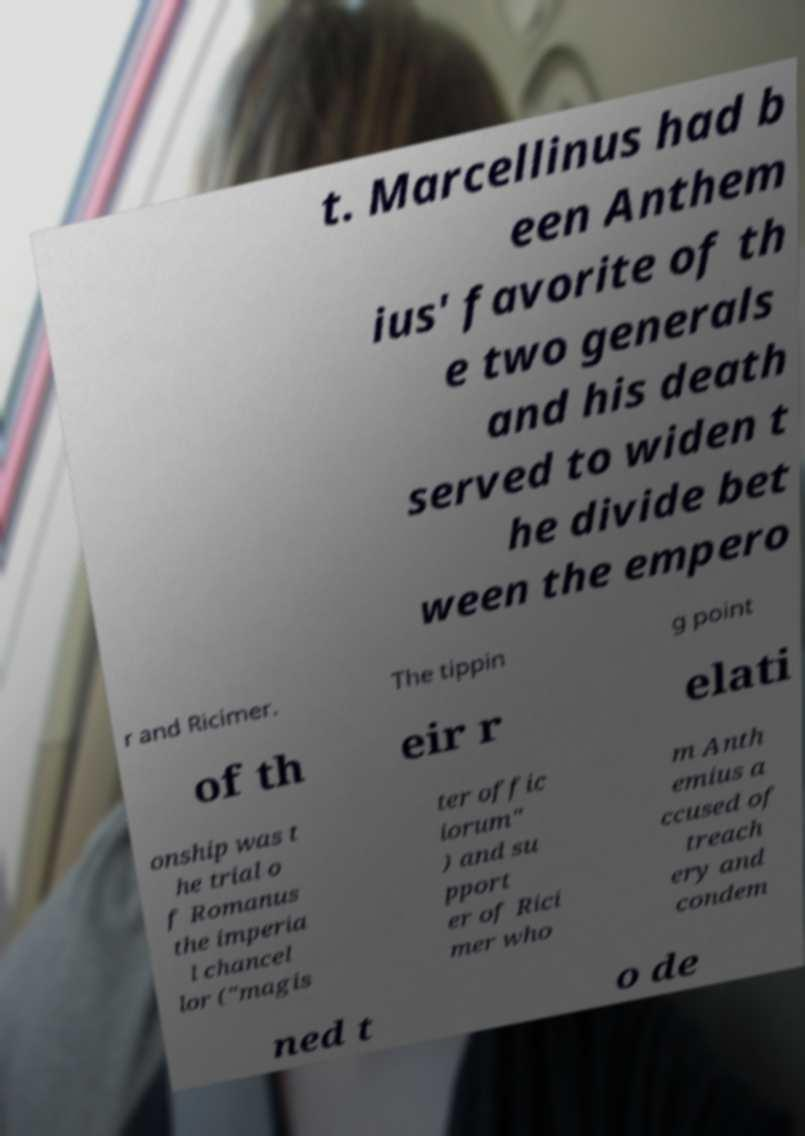I need the written content from this picture converted into text. Can you do that? t. Marcellinus had b een Anthem ius' favorite of th e two generals and his death served to widen t he divide bet ween the empero r and Ricimer. The tippin g point of th eir r elati onship was t he trial o f Romanus the imperia l chancel lor ("magis ter offic iorum" ) and su pport er of Rici mer who m Anth emius a ccused of treach ery and condem ned t o de 